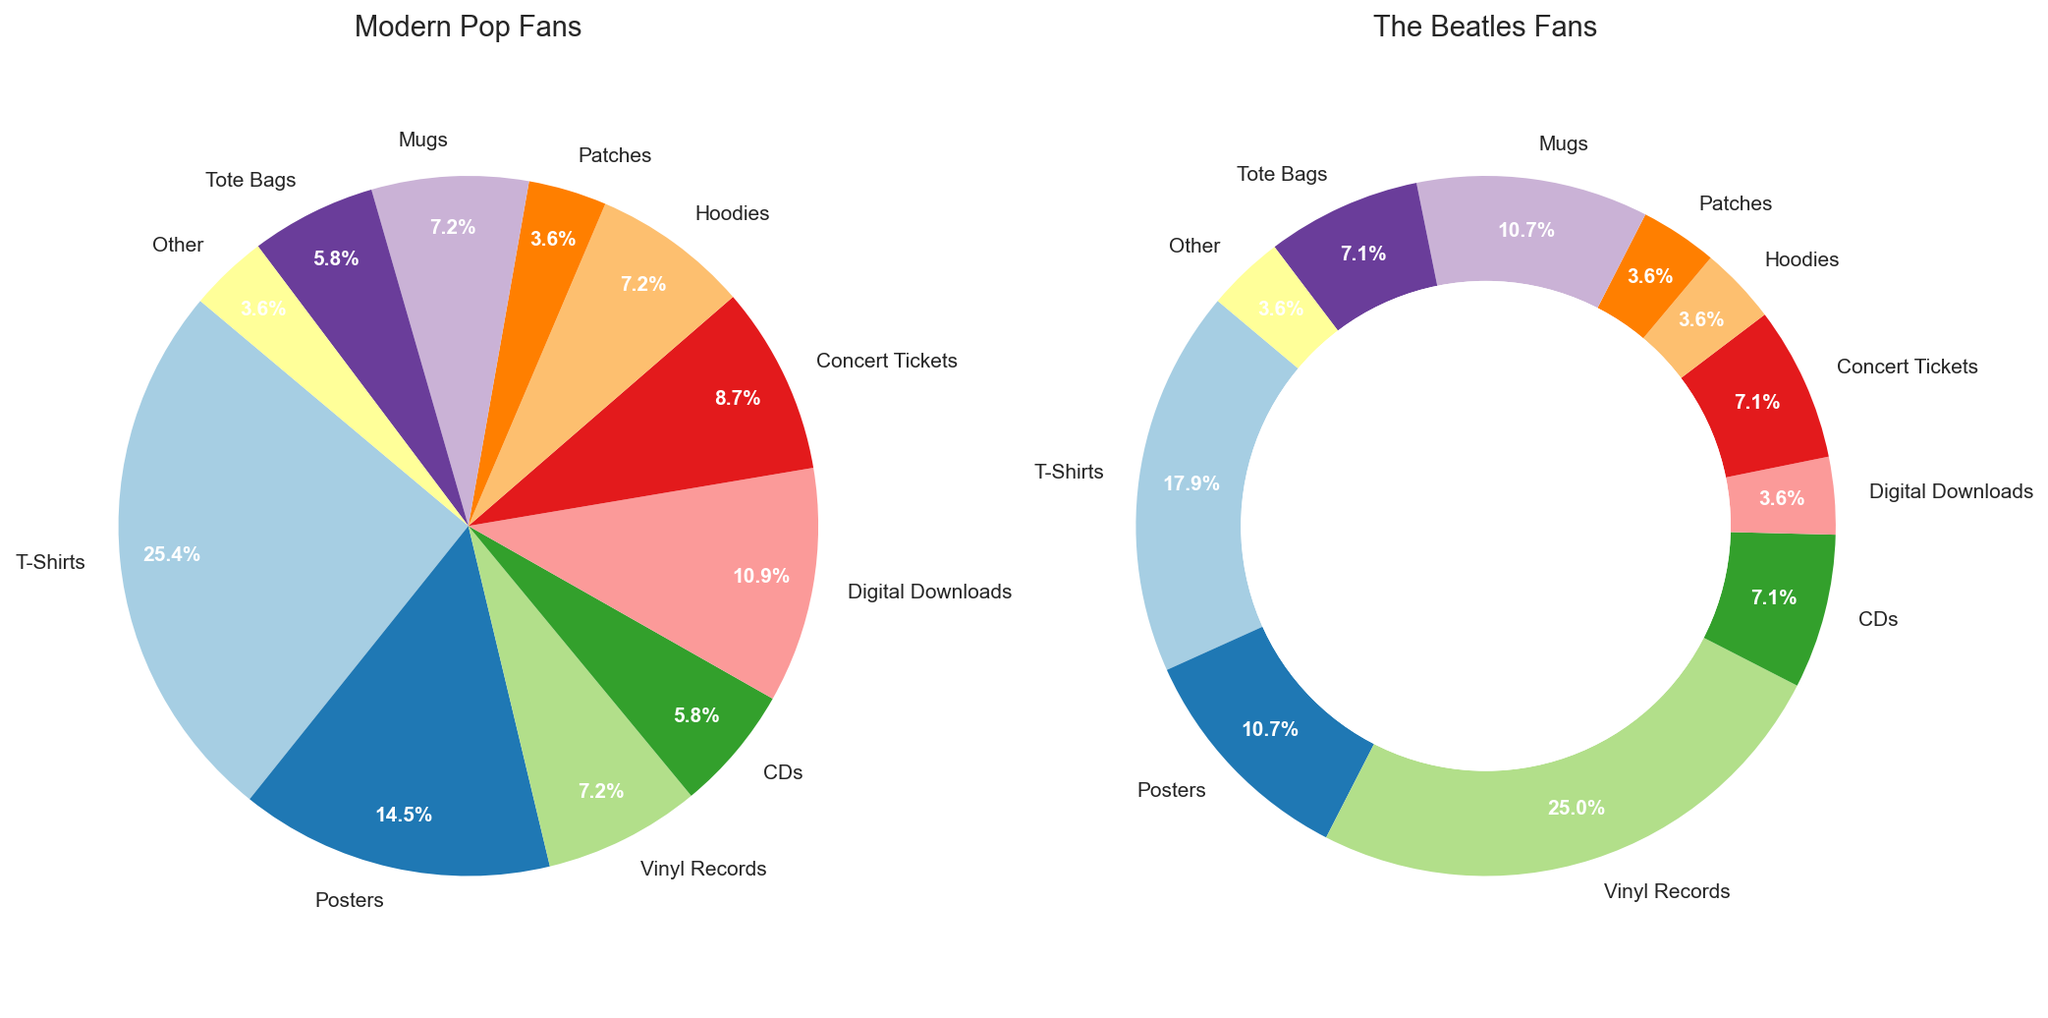Which type of merchandise is most popular among Modern Pop Fans? To answer this, look for the segment of the pie chart with the largest percentage under the "Modern Pop Fans" title. The T-Shirts segment is the largest.
Answer: T-Shirts What percentage of Modern Pop Fans purchased Hoodies compared to The Beatles Fans? Compare the "Hoodies" segments in both pie charts. Modern Pop Fans bought 10 out of a total of 135 merchandise items, and The Beatles Fans bought 5 out of 140. Divide and multiply by 100 to get the percentages. Modern Pop Fans: (10/135)*100 ≈ 7.4%, The Beatles Fans: (5/140)*100 ≈ 3.6%.
Answer: ~7.4% vs. ~3.6% Which merchandise type has the biggest difference in popularity between the two fan groups? Identify the merchandise type with the largest percentage difference between the two charts. Vinyl Records have a significant discrepancy (10% for Modern Pop Fans and 35% for The Beatles Fans).
Answer: Vinyl Records What is the total number of concert tickets purchased by both groups? Sum the values for "Concert Tickets" in both charts: 12 (Modern Pop Fans) + 10 (The Beatles Fans) = 22.
Answer: 22 Which group buys more T-Shirts: Modern Pop Fans or The Beatles Fans? Compare the "T-Shirts" segments in both pie charts. Modern Pop Fans have 35, while The Beatles Fans have 25.
Answer: Modern Pop Fans What is the combined percentage of T-Shirts and Posters bought by Modern Pop Fans? Add the percentages for "T-Shirts" and "Posters". T-Shirts: 35 out of 135, Posters: 20 out of 135. Percentage = (35 + 20)/135 * 100 ≈ (55/135) * 100 ≈ 40.7%.
Answer: ~40.7% Which merchandise type has an equal percentage for both groups? Identify any segments that are the same size in both pie charts. The "Patches" segment is the same for both groups (5 merchandise items each).
Answer: Patches What is the ratio of T-Shirts to Vinyl Records purchases by Modern Pop Fans? The Modern Pop Fans purchase 35 T-Shirts and 10 Vinyl Records. The ratio is 35:10, which simplifies to 7:2.
Answer: 7:2 If you combine the purchases of Mugs and Tote Bags, which group buys more? Calculate the total purchases of "Mugs" and "Tote Bags" for each group. Modern Pop Fans: 10 (Mugs) + 8 (Tote Bags) = 18. The Beatles Fans: 15 (Mugs) + 10 (Tote Bags) = 25. The Beatles Fans buy more.
Answer: The Beatles Fans 